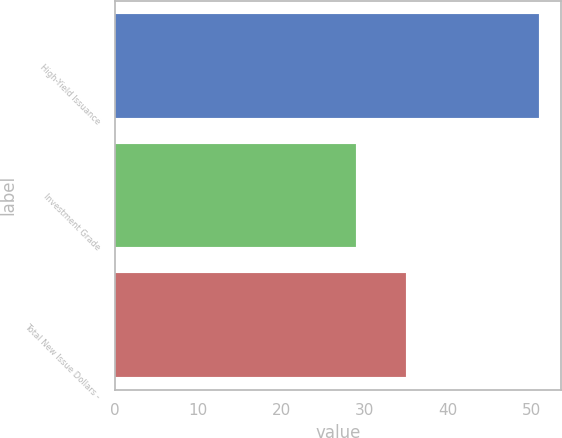Convert chart. <chart><loc_0><loc_0><loc_500><loc_500><bar_chart><fcel>High-Yield Issuance<fcel>Investment Grade<fcel>Total New Issue Dollars -<nl><fcel>51<fcel>29<fcel>35<nl></chart> 